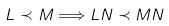<formula> <loc_0><loc_0><loc_500><loc_500>L \prec M \Longrightarrow L N \prec M N</formula> 